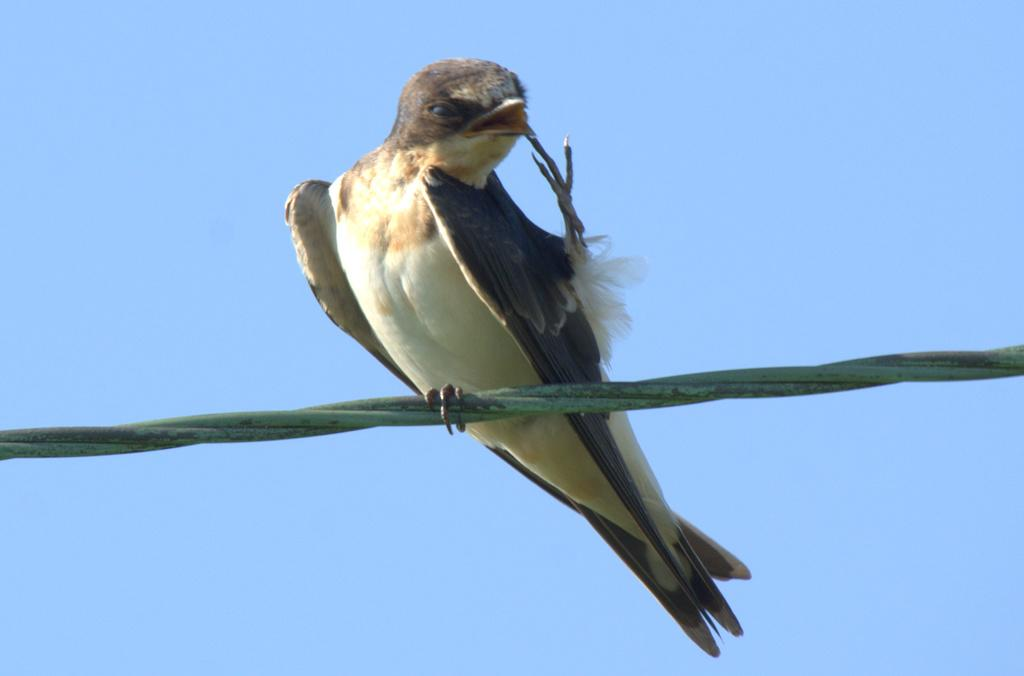What is the main subject of the image? There is a bird in the image. Where is the bird located? The bird is sitting on a cable. What can be seen in the background of the image? The sky is visible in the background of the image. What is the color of the sky? The color of the sky is blue. What type of noise can be heard coming from the bird in the image? There is no indication of any noise in the image, so it cannot be determined from the image. 